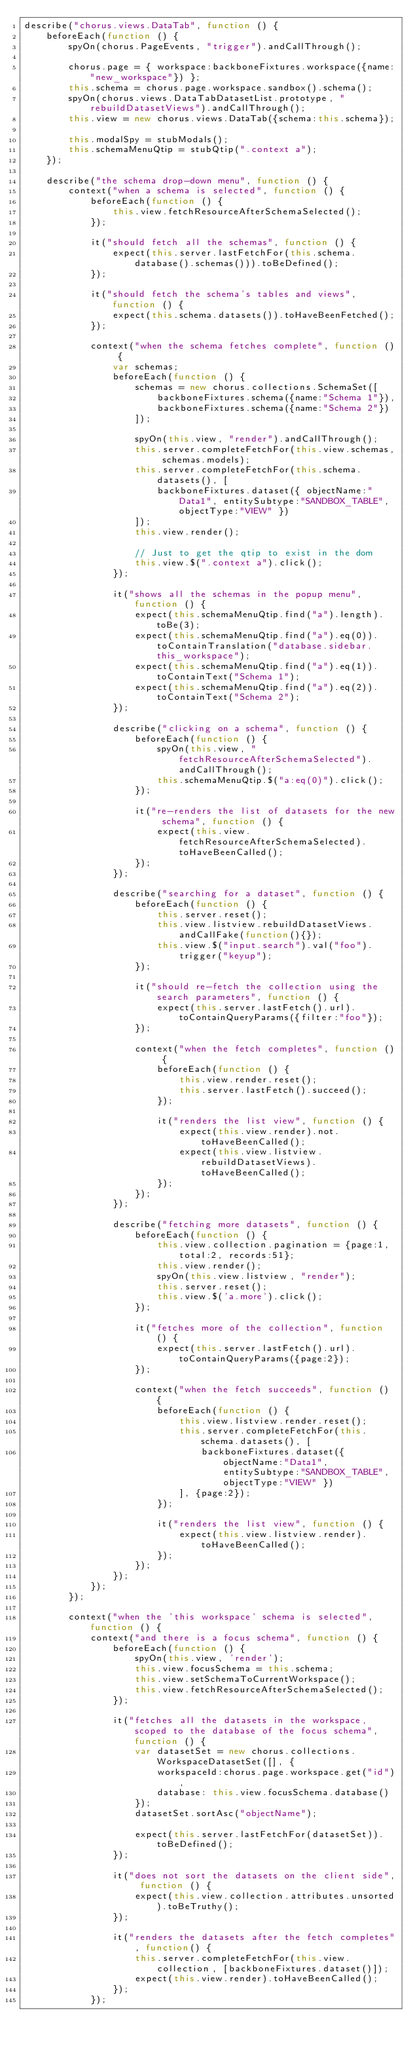Convert code to text. <code><loc_0><loc_0><loc_500><loc_500><_JavaScript_>describe("chorus.views.DataTab", function () {
    beforeEach(function () {
        spyOn(chorus.PageEvents, "trigger").andCallThrough();

        chorus.page = { workspace:backboneFixtures.workspace({name:"new_workspace"}) };
        this.schema = chorus.page.workspace.sandbox().schema();
        spyOn(chorus.views.DataTabDatasetList.prototype, "rebuildDatasetViews").andCallThrough();
        this.view = new chorus.views.DataTab({schema:this.schema});

        this.modalSpy = stubModals();
        this.schemaMenuQtip = stubQtip(".context a");
    });

    describe("the schema drop-down menu", function () {
        context("when a schema is selected", function () {
            beforeEach(function () {
                this.view.fetchResourceAfterSchemaSelected();
            });

            it("should fetch all the schemas", function () {
                expect(this.server.lastFetchFor(this.schema.database().schemas())).toBeDefined();
            });

            it("should fetch the schema's tables and views", function () {
                expect(this.schema.datasets()).toHaveBeenFetched();
            });

            context("when the schema fetches complete", function () {
                var schemas;
                beforeEach(function () {
                    schemas = new chorus.collections.SchemaSet([
                        backboneFixtures.schema({name:"Schema 1"}),
                        backboneFixtures.schema({name:"Schema 2"})
                    ]);

                    spyOn(this.view, "render").andCallThrough();
                    this.server.completeFetchFor(this.view.schemas, schemas.models);
                    this.server.completeFetchFor(this.schema.datasets(), [
                        backboneFixtures.dataset({ objectName:"Data1", entitySubtype:"SANDBOX_TABLE", objectType:"VIEW" })
                    ]);
                    this.view.render();

                    // Just to get the qtip to exist in the dom
                    this.view.$(".context a").click();
                });

                it("shows all the schemas in the popup menu", function () {
                    expect(this.schemaMenuQtip.find("a").length).toBe(3);
                    expect(this.schemaMenuQtip.find("a").eq(0)).toContainTranslation("database.sidebar.this_workspace");
                    expect(this.schemaMenuQtip.find("a").eq(1)).toContainText("Schema 1");
                    expect(this.schemaMenuQtip.find("a").eq(2)).toContainText("Schema 2");
                });

                describe("clicking on a schema", function () {
                    beforeEach(function () {
                        spyOn(this.view, "fetchResourceAfterSchemaSelected").andCallThrough();
                        this.schemaMenuQtip.$("a:eq(0)").click();
                    });

                    it("re-renders the list of datasets for the new schema", function () {
                        expect(this.view.fetchResourceAfterSchemaSelected).toHaveBeenCalled();
                    });
                });

                describe("searching for a dataset", function () {
                    beforeEach(function () {
                        this.server.reset();
                        this.view.listview.rebuildDatasetViews.andCallFake(function(){});
                        this.view.$("input.search").val("foo").trigger("keyup");
                    });

                    it("should re-fetch the collection using the search parameters", function () {
                        expect(this.server.lastFetch().url).toContainQueryParams({filter:"foo"});
                    });

                    context("when the fetch completes", function () {
                        beforeEach(function () {
                            this.view.render.reset();
                            this.server.lastFetch().succeed();
                        });

                        it("renders the list view", function () {
                            expect(this.view.render).not.toHaveBeenCalled();
                            expect(this.view.listview.rebuildDatasetViews).toHaveBeenCalled();
                        });
                    });
                });

                describe("fetching more datasets", function () {
                    beforeEach(function () {
                        this.view.collection.pagination = {page:1, total:2, records:51};
                        this.view.render();
                        spyOn(this.view.listview, "render");
                        this.server.reset();
                        this.view.$('a.more').click();
                    });

                    it("fetches more of the collection", function () {
                        expect(this.server.lastFetch().url).toContainQueryParams({page:2});
                    });

                    context("when the fetch succeeds", function () {
                        beforeEach(function () {
                            this.view.listview.render.reset();
                            this.server.completeFetchFor(this.schema.datasets(), [
                                backboneFixtures.dataset({ objectName:"Data1", entitySubtype:"SANDBOX_TABLE", objectType:"VIEW" })
                            ], {page:2});
                        });

                        it("renders the list view", function () {
                            expect(this.view.listview.render).toHaveBeenCalled();
                        });
                    });
                });
            });
        });

        context("when the 'this workspace' schema is selected", function () {
            context("and there is a focus schema", function () {
                beforeEach(function () {
                    spyOn(this.view, 'render');
                    this.view.focusSchema = this.schema;
                    this.view.setSchemaToCurrentWorkspace();
                    this.view.fetchResourceAfterSchemaSelected();
                });

                it("fetches all the datasets in the workspace, scoped to the database of the focus schema", function () {
                    var datasetSet = new chorus.collections.WorkspaceDatasetSet([], {
                        workspaceId:chorus.page.workspace.get("id"),
                        database: this.view.focusSchema.database()
                    });
                    datasetSet.sortAsc("objectName");

                    expect(this.server.lastFetchFor(datasetSet)).toBeDefined();
                });

                it("does not sort the datasets on the client side", function () {
                    expect(this.view.collection.attributes.unsorted).toBeTruthy();
                });

                it("renders the datasets after the fetch completes", function() {
                    this.server.completeFetchFor(this.view.collection, [backboneFixtures.dataset()]);
                    expect(this.view.render).toHaveBeenCalled();
                });
            });
</code> 